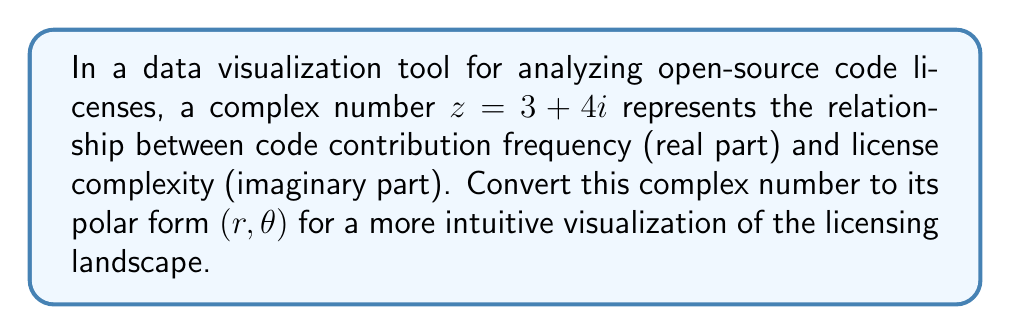Can you solve this math problem? To convert the complex number $z = 3 + 4i$ from rectangular form to polar form $(r, \theta)$, we follow these steps:

1. Calculate the modulus $r$:
   $$r = \sqrt{a^2 + b^2}$$
   where $a$ is the real part and $b$ is the imaginary part.
   $$r = \sqrt{3^2 + 4^2} = \sqrt{9 + 16} = \sqrt{25} = 5$$

2. Calculate the argument $\theta$:
   $$\theta = \arctan(\frac{b}{a})$$
   $$\theta = \arctan(\frac{4}{3})$$

3. Evaluate $\arctan(\frac{4}{3})$:
   $$\theta \approx 0.9272952180 \text{ radians}$$

4. Convert radians to degrees (optional, for better interpretation):
   $$\theta \approx 0.9272952180 \times \frac{180}{\pi} \approx 53.13010235^\circ$$

Therefore, the polar form of $z = 3 + 4i$ is $(5, 0.9272952180)$ in radians or $(5, 53.13010235^\circ)$ in degrees.
Answer: $(5, 0.9272952180)$ radians or $(5, 53.13010235^\circ)$ 